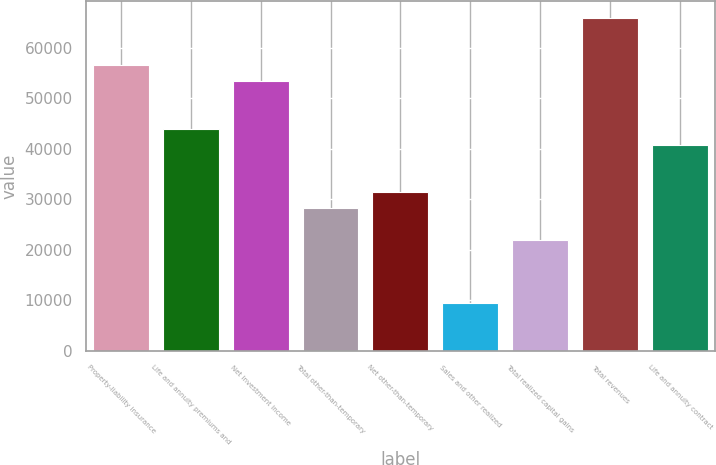Convert chart to OTSL. <chart><loc_0><loc_0><loc_500><loc_500><bar_chart><fcel>Property-liability insurance<fcel>Life and annuity premiums and<fcel>Net investment income<fcel>Total other-than-temporary<fcel>Net other-than-temporary<fcel>Sales and other realized<fcel>Total realized capital gains<fcel>Total revenues<fcel>Life and annuity contract<nl><fcel>56511.2<fcel>43955.6<fcel>53372.3<fcel>28261.1<fcel>31400<fcel>9427.7<fcel>21983.3<fcel>65927.9<fcel>40816.7<nl></chart> 